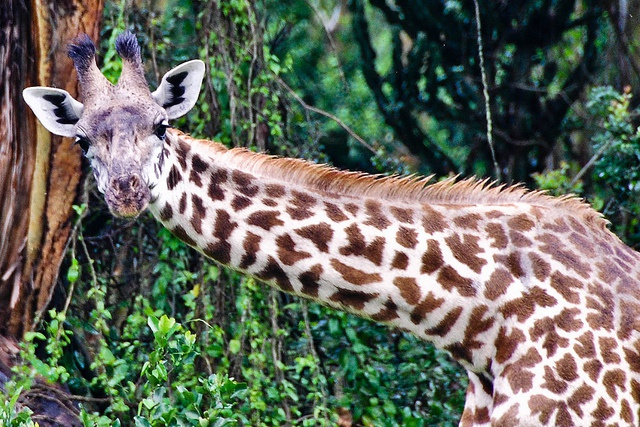Describe the objects in this image and their specific colors. I can see a giraffe in black, lightgray, brown, darkgray, and pink tones in this image. 